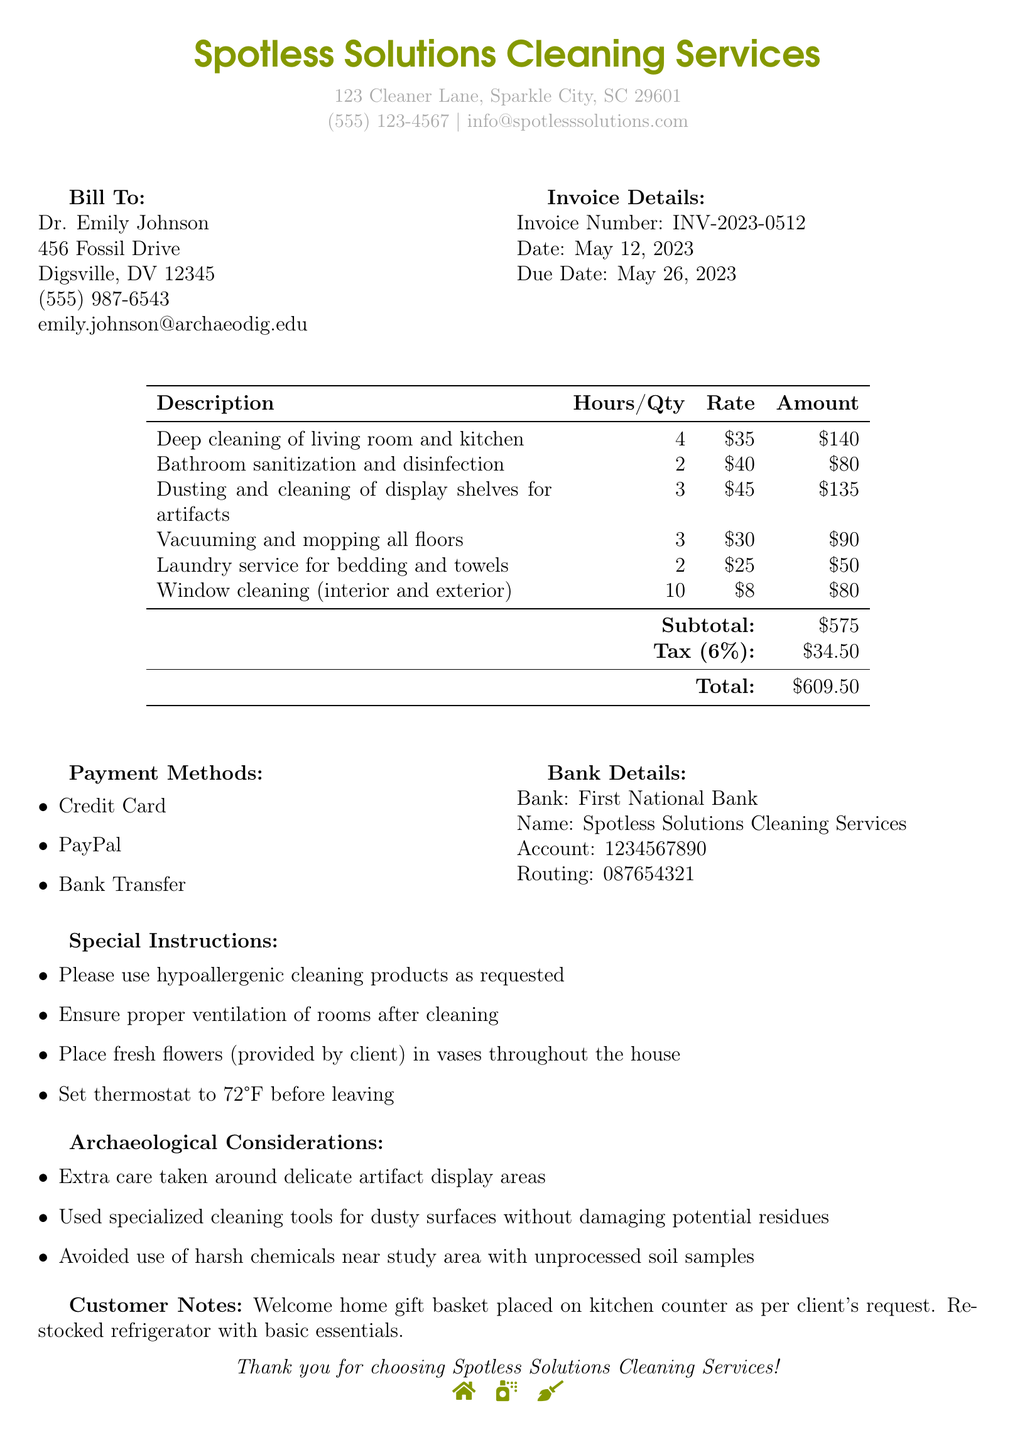What is the invoice number? The invoice number is a unique identifier for this transaction, which is provided at the top of the document.
Answer: INV-2023-0512 What is the due date for payment? The due date indicates by when the client needs to make the payment for the cleaning services.
Answer: May 26, 2023 How many hours were spent on bathroom sanitization? This question asks for the number of hours dedicated to a specific service listed in the service items.
Answer: 2 What is the total amount due? The total amount reflects the sum of all service costs, including tax, presented at the end of the document.
Answer: $609.50 What special instruction was given about the cleaning products? This instruction specifies the type of cleaning products that should be used during the service, reflecting the client's preferences.
Answer: hypoallergenic cleaning products Which method of payment is mentioned? The document lists the available payment methods for settling the invoice.
Answer: Credit Card What was done with the gift basket? This question pertains to the customer notes regarding additional services provided post-cleaning.
Answer: placed on kitchen counter What bank is associated with Spotless Solutions Cleaning Services? This asks for the name of the bank where payments should be directed, as listed in the bank details section.
Answer: First National Bank What care was taken in regard to artifact display areas? This question assesses understanding of the specific considerations taken during the cleaning process to protect delicate items.
Answer: Extra care taken What type of service was provided for windows? This question refers to a specific service included in the invoice detailing what was performed.
Answer: Window cleaning (interior and exterior) 